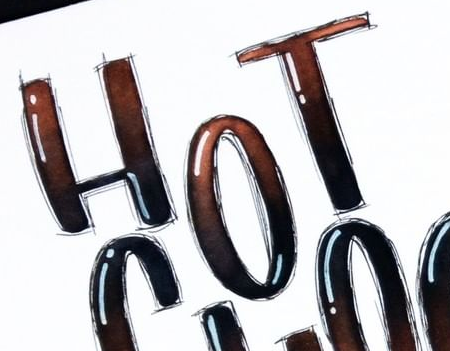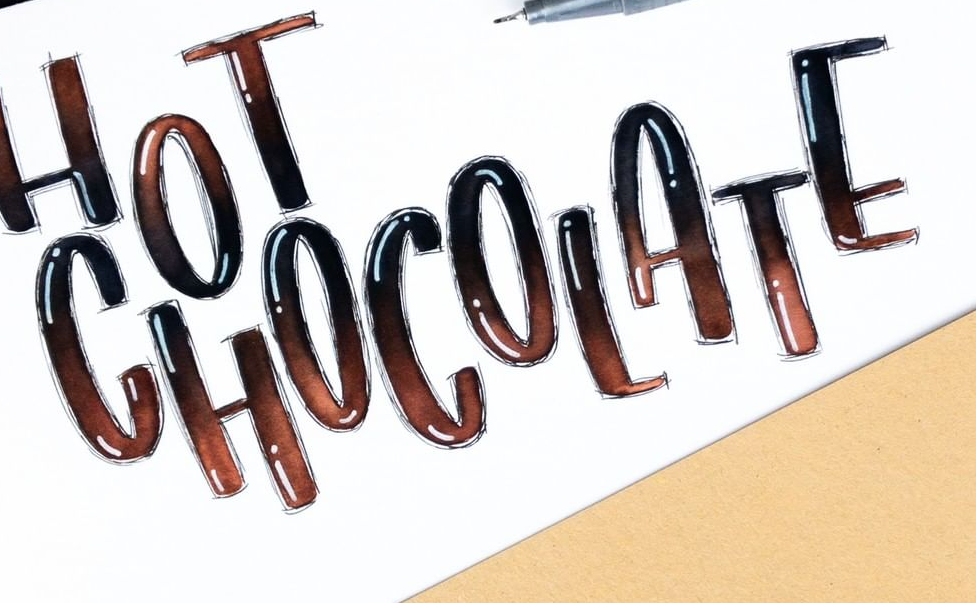Read the text from these images in sequence, separated by a semicolon. HOT; CHOCOLATE 